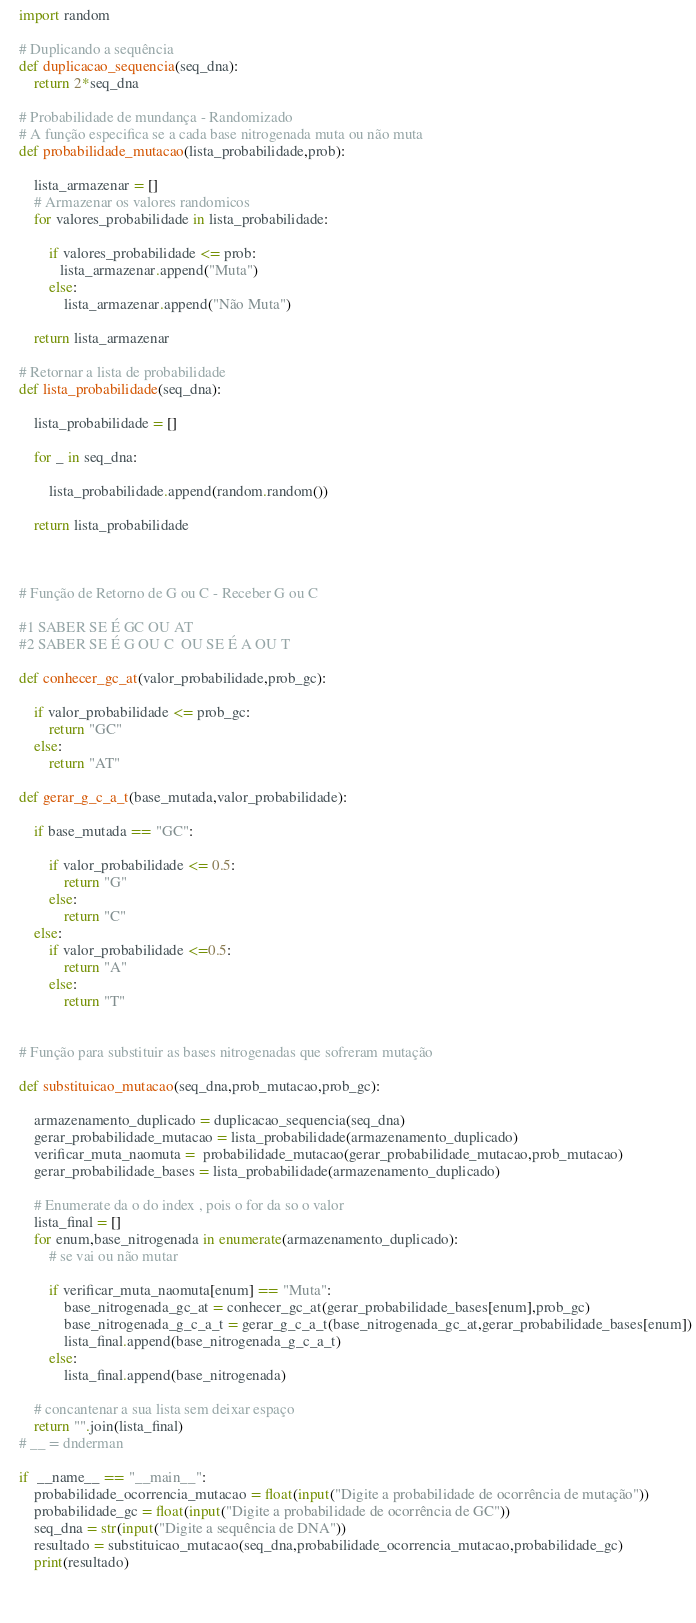<code> <loc_0><loc_0><loc_500><loc_500><_Python_>import random

# Duplicando a sequência
def duplicacao_sequencia(seq_dna):
    return 2*seq_dna

# Probabilidade de mundança - Randomizado
# A função especifica se a cada base nitrogenada muta ou não muta
def probabilidade_mutacao(lista_probabilidade,prob):
    
    lista_armazenar = []
    # Armazenar os valores randomicos
    for valores_probabilidade in lista_probabilidade:

        if valores_probabilidade <= prob:
           lista_armazenar.append("Muta") 
        else:
            lista_armazenar.append("Não Muta")
    
    return lista_armazenar

# Retornar a lista de probabilidade
def lista_probabilidade(seq_dna):

    lista_probabilidade = []

    for _ in seq_dna:
        
        lista_probabilidade.append(random.random())

    return lista_probabilidade



# Função de Retorno de G ou C - Receber G ou C

#1 SABER SE É GC OU AT
#2 SABER SE É G OU C  OU SE É A OU T

def conhecer_gc_at(valor_probabilidade,prob_gc):

    if valor_probabilidade <= prob_gc:
        return "GC"
    else:
        return "AT"

def gerar_g_c_a_t(base_mutada,valor_probabilidade):

    if base_mutada == "GC":

        if valor_probabilidade <= 0.5:
            return "G"
        else:
            return "C"
    else:
        if valor_probabilidade <=0.5:
            return "A"
        else:
            return "T"


# Função para substituir as bases nitrogenadas que sofreram mutação

def substituicao_mutacao(seq_dna,prob_mutacao,prob_gc):

    armazenamento_duplicado = duplicacao_sequencia(seq_dna)
    gerar_probabilidade_mutacao = lista_probabilidade(armazenamento_duplicado)
    verificar_muta_naomuta =  probabilidade_mutacao(gerar_probabilidade_mutacao,prob_mutacao)
    gerar_probabilidade_bases = lista_probabilidade(armazenamento_duplicado)

    # Enumerate da o do index , pois o for da so o valor
    lista_final = []
    for enum,base_nitrogenada in enumerate(armazenamento_duplicado):
        # se vai ou não mutar 

        if verificar_muta_naomuta[enum] == "Muta":
            base_nitrogenada_gc_at = conhecer_gc_at(gerar_probabilidade_bases[enum],prob_gc)
            base_nitrogenada_g_c_a_t = gerar_g_c_a_t(base_nitrogenada_gc_at,gerar_probabilidade_bases[enum])
            lista_final.append(base_nitrogenada_g_c_a_t)
        else:
            lista_final.append(base_nitrogenada)

    # concantenar a sua lista sem deixar espaço
    return "".join(lista_final)
# __ = dnderman

if  __name__ == "__main__":
    probabilidade_ocorrencia_mutacao = float(input("Digite a probabilidade de ocorrência de mutação"))
    probabilidade_gc = float(input("Digite a probabilidade de ocorrência de GC"))
    seq_dna = str(input("Digite a sequência de DNA"))
    resultado = substituicao_mutacao(seq_dna,probabilidade_ocorrencia_mutacao,probabilidade_gc)
    print(resultado)


    








</code> 